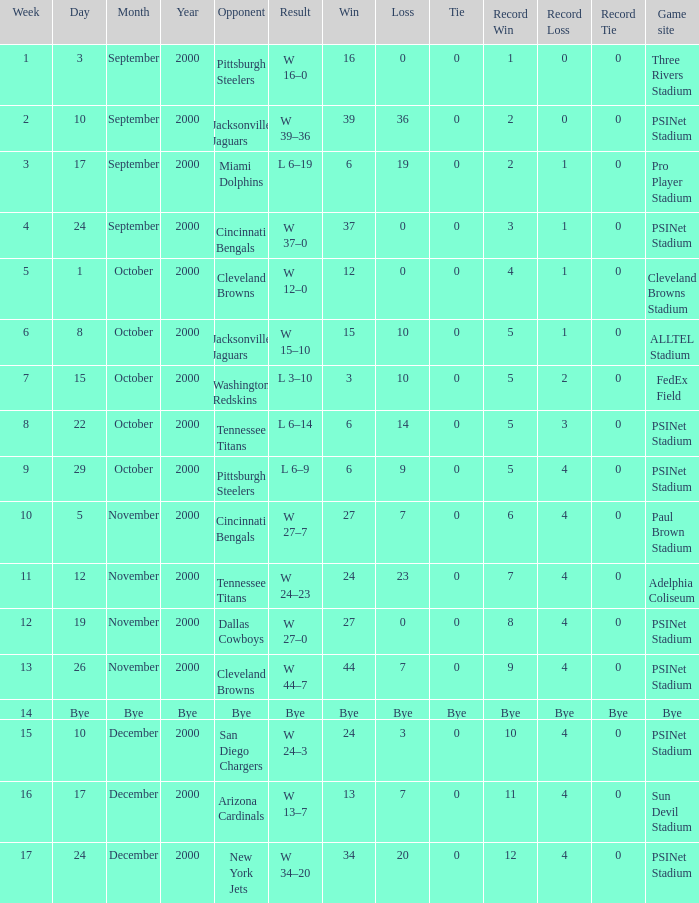What's the record for October 8, 2000 before week 13? 5–1–0. 